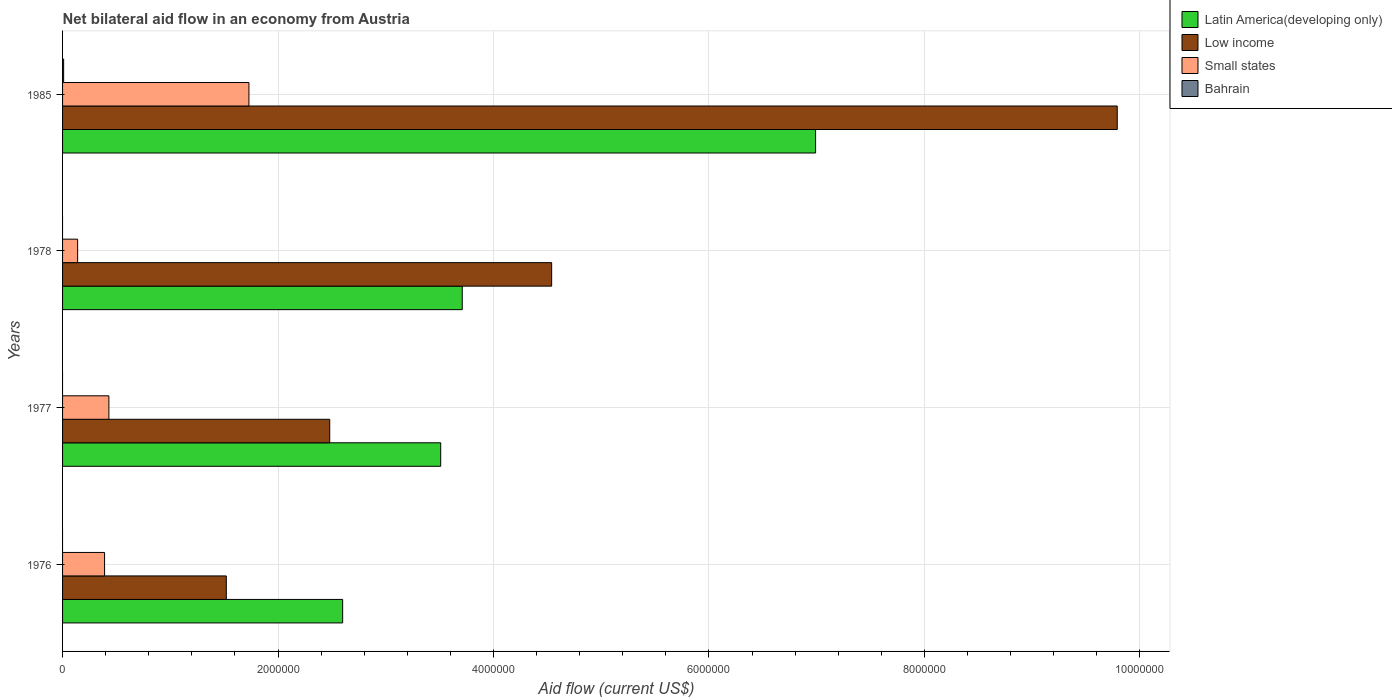How many different coloured bars are there?
Offer a terse response. 4. Are the number of bars per tick equal to the number of legend labels?
Your response must be concise. No. Are the number of bars on each tick of the Y-axis equal?
Provide a succinct answer. No. How many bars are there on the 1st tick from the top?
Offer a terse response. 4. How many bars are there on the 1st tick from the bottom?
Offer a terse response. 3. What is the net bilateral aid flow in Low income in 1978?
Provide a succinct answer. 4.54e+06. Across all years, what is the maximum net bilateral aid flow in Low income?
Provide a succinct answer. 9.79e+06. Across all years, what is the minimum net bilateral aid flow in Low income?
Your response must be concise. 1.52e+06. In which year was the net bilateral aid flow in Bahrain maximum?
Provide a succinct answer. 1985. What is the total net bilateral aid flow in Small states in the graph?
Provide a short and direct response. 2.69e+06. What is the difference between the net bilateral aid flow in Small states in 1976 and that in 1978?
Make the answer very short. 2.50e+05. What is the difference between the net bilateral aid flow in Latin America(developing only) in 1978 and the net bilateral aid flow in Bahrain in 1976?
Make the answer very short. 3.71e+06. What is the average net bilateral aid flow in Latin America(developing only) per year?
Make the answer very short. 4.20e+06. In the year 1985, what is the difference between the net bilateral aid flow in Low income and net bilateral aid flow in Latin America(developing only)?
Provide a short and direct response. 2.80e+06. What is the ratio of the net bilateral aid flow in Low income in 1977 to that in 1978?
Keep it short and to the point. 0.55. Is the net bilateral aid flow in Small states in 1977 less than that in 1978?
Your response must be concise. No. Is the difference between the net bilateral aid flow in Low income in 1976 and 1985 greater than the difference between the net bilateral aid flow in Latin America(developing only) in 1976 and 1985?
Your response must be concise. No. What is the difference between the highest and the second highest net bilateral aid flow in Latin America(developing only)?
Your answer should be compact. 3.28e+06. What is the difference between the highest and the lowest net bilateral aid flow in Low income?
Give a very brief answer. 8.27e+06. Is the sum of the net bilateral aid flow in Low income in 1976 and 1985 greater than the maximum net bilateral aid flow in Latin America(developing only) across all years?
Make the answer very short. Yes. Is it the case that in every year, the sum of the net bilateral aid flow in Low income and net bilateral aid flow in Small states is greater than the sum of net bilateral aid flow in Bahrain and net bilateral aid flow in Latin America(developing only)?
Your answer should be compact. No. Is it the case that in every year, the sum of the net bilateral aid flow in Latin America(developing only) and net bilateral aid flow in Bahrain is greater than the net bilateral aid flow in Low income?
Give a very brief answer. No. How many bars are there?
Provide a short and direct response. 13. Are all the bars in the graph horizontal?
Your answer should be compact. Yes. What is the difference between two consecutive major ticks on the X-axis?
Keep it short and to the point. 2.00e+06. Does the graph contain any zero values?
Your answer should be very brief. Yes. What is the title of the graph?
Give a very brief answer. Net bilateral aid flow in an economy from Austria. Does "Euro area" appear as one of the legend labels in the graph?
Offer a terse response. No. What is the label or title of the Y-axis?
Make the answer very short. Years. What is the Aid flow (current US$) in Latin America(developing only) in 1976?
Make the answer very short. 2.60e+06. What is the Aid flow (current US$) in Low income in 1976?
Your answer should be very brief. 1.52e+06. What is the Aid flow (current US$) of Small states in 1976?
Provide a short and direct response. 3.90e+05. What is the Aid flow (current US$) in Latin America(developing only) in 1977?
Give a very brief answer. 3.51e+06. What is the Aid flow (current US$) in Low income in 1977?
Keep it short and to the point. 2.48e+06. What is the Aid flow (current US$) in Small states in 1977?
Make the answer very short. 4.30e+05. What is the Aid flow (current US$) in Latin America(developing only) in 1978?
Offer a very short reply. 3.71e+06. What is the Aid flow (current US$) in Low income in 1978?
Offer a very short reply. 4.54e+06. What is the Aid flow (current US$) of Latin America(developing only) in 1985?
Make the answer very short. 6.99e+06. What is the Aid flow (current US$) of Low income in 1985?
Offer a terse response. 9.79e+06. What is the Aid flow (current US$) of Small states in 1985?
Provide a short and direct response. 1.73e+06. What is the Aid flow (current US$) of Bahrain in 1985?
Make the answer very short. 10000. Across all years, what is the maximum Aid flow (current US$) of Latin America(developing only)?
Ensure brevity in your answer.  6.99e+06. Across all years, what is the maximum Aid flow (current US$) in Low income?
Your response must be concise. 9.79e+06. Across all years, what is the maximum Aid flow (current US$) in Small states?
Make the answer very short. 1.73e+06. Across all years, what is the minimum Aid flow (current US$) in Latin America(developing only)?
Provide a succinct answer. 2.60e+06. Across all years, what is the minimum Aid flow (current US$) in Low income?
Provide a short and direct response. 1.52e+06. Across all years, what is the minimum Aid flow (current US$) of Small states?
Keep it short and to the point. 1.40e+05. What is the total Aid flow (current US$) of Latin America(developing only) in the graph?
Provide a succinct answer. 1.68e+07. What is the total Aid flow (current US$) of Low income in the graph?
Your response must be concise. 1.83e+07. What is the total Aid flow (current US$) in Small states in the graph?
Your answer should be compact. 2.69e+06. What is the difference between the Aid flow (current US$) of Latin America(developing only) in 1976 and that in 1977?
Your response must be concise. -9.10e+05. What is the difference between the Aid flow (current US$) in Low income in 1976 and that in 1977?
Ensure brevity in your answer.  -9.60e+05. What is the difference between the Aid flow (current US$) in Latin America(developing only) in 1976 and that in 1978?
Your answer should be compact. -1.11e+06. What is the difference between the Aid flow (current US$) in Low income in 1976 and that in 1978?
Your answer should be very brief. -3.02e+06. What is the difference between the Aid flow (current US$) of Small states in 1976 and that in 1978?
Provide a succinct answer. 2.50e+05. What is the difference between the Aid flow (current US$) of Latin America(developing only) in 1976 and that in 1985?
Your answer should be compact. -4.39e+06. What is the difference between the Aid flow (current US$) of Low income in 1976 and that in 1985?
Keep it short and to the point. -8.27e+06. What is the difference between the Aid flow (current US$) of Small states in 1976 and that in 1985?
Your answer should be very brief. -1.34e+06. What is the difference between the Aid flow (current US$) of Low income in 1977 and that in 1978?
Your response must be concise. -2.06e+06. What is the difference between the Aid flow (current US$) in Latin America(developing only) in 1977 and that in 1985?
Offer a very short reply. -3.48e+06. What is the difference between the Aid flow (current US$) in Low income in 1977 and that in 1985?
Make the answer very short. -7.31e+06. What is the difference between the Aid flow (current US$) of Small states in 1977 and that in 1985?
Offer a terse response. -1.30e+06. What is the difference between the Aid flow (current US$) in Latin America(developing only) in 1978 and that in 1985?
Ensure brevity in your answer.  -3.28e+06. What is the difference between the Aid flow (current US$) in Low income in 1978 and that in 1985?
Give a very brief answer. -5.25e+06. What is the difference between the Aid flow (current US$) of Small states in 1978 and that in 1985?
Provide a succinct answer. -1.59e+06. What is the difference between the Aid flow (current US$) in Latin America(developing only) in 1976 and the Aid flow (current US$) in Low income in 1977?
Your answer should be compact. 1.20e+05. What is the difference between the Aid flow (current US$) in Latin America(developing only) in 1976 and the Aid flow (current US$) in Small states in 1977?
Offer a terse response. 2.17e+06. What is the difference between the Aid flow (current US$) in Low income in 1976 and the Aid flow (current US$) in Small states in 1977?
Provide a succinct answer. 1.09e+06. What is the difference between the Aid flow (current US$) in Latin America(developing only) in 1976 and the Aid flow (current US$) in Low income in 1978?
Give a very brief answer. -1.94e+06. What is the difference between the Aid flow (current US$) of Latin America(developing only) in 1976 and the Aid flow (current US$) of Small states in 1978?
Keep it short and to the point. 2.46e+06. What is the difference between the Aid flow (current US$) in Low income in 1976 and the Aid flow (current US$) in Small states in 1978?
Make the answer very short. 1.38e+06. What is the difference between the Aid flow (current US$) in Latin America(developing only) in 1976 and the Aid flow (current US$) in Low income in 1985?
Provide a short and direct response. -7.19e+06. What is the difference between the Aid flow (current US$) of Latin America(developing only) in 1976 and the Aid flow (current US$) of Small states in 1985?
Ensure brevity in your answer.  8.70e+05. What is the difference between the Aid flow (current US$) of Latin America(developing only) in 1976 and the Aid flow (current US$) of Bahrain in 1985?
Provide a short and direct response. 2.59e+06. What is the difference between the Aid flow (current US$) of Low income in 1976 and the Aid flow (current US$) of Bahrain in 1985?
Your response must be concise. 1.51e+06. What is the difference between the Aid flow (current US$) in Latin America(developing only) in 1977 and the Aid flow (current US$) in Low income in 1978?
Make the answer very short. -1.03e+06. What is the difference between the Aid flow (current US$) of Latin America(developing only) in 1977 and the Aid flow (current US$) of Small states in 1978?
Provide a succinct answer. 3.37e+06. What is the difference between the Aid flow (current US$) of Low income in 1977 and the Aid flow (current US$) of Small states in 1978?
Your answer should be very brief. 2.34e+06. What is the difference between the Aid flow (current US$) in Latin America(developing only) in 1977 and the Aid flow (current US$) in Low income in 1985?
Make the answer very short. -6.28e+06. What is the difference between the Aid flow (current US$) in Latin America(developing only) in 1977 and the Aid flow (current US$) in Small states in 1985?
Your answer should be compact. 1.78e+06. What is the difference between the Aid flow (current US$) in Latin America(developing only) in 1977 and the Aid flow (current US$) in Bahrain in 1985?
Ensure brevity in your answer.  3.50e+06. What is the difference between the Aid flow (current US$) in Low income in 1977 and the Aid flow (current US$) in Small states in 1985?
Provide a short and direct response. 7.50e+05. What is the difference between the Aid flow (current US$) of Low income in 1977 and the Aid flow (current US$) of Bahrain in 1985?
Offer a terse response. 2.47e+06. What is the difference between the Aid flow (current US$) in Latin America(developing only) in 1978 and the Aid flow (current US$) in Low income in 1985?
Offer a very short reply. -6.08e+06. What is the difference between the Aid flow (current US$) of Latin America(developing only) in 1978 and the Aid flow (current US$) of Small states in 1985?
Provide a short and direct response. 1.98e+06. What is the difference between the Aid flow (current US$) of Latin America(developing only) in 1978 and the Aid flow (current US$) of Bahrain in 1985?
Ensure brevity in your answer.  3.70e+06. What is the difference between the Aid flow (current US$) in Low income in 1978 and the Aid flow (current US$) in Small states in 1985?
Offer a terse response. 2.81e+06. What is the difference between the Aid flow (current US$) of Low income in 1978 and the Aid flow (current US$) of Bahrain in 1985?
Ensure brevity in your answer.  4.53e+06. What is the difference between the Aid flow (current US$) of Small states in 1978 and the Aid flow (current US$) of Bahrain in 1985?
Ensure brevity in your answer.  1.30e+05. What is the average Aid flow (current US$) of Latin America(developing only) per year?
Provide a short and direct response. 4.20e+06. What is the average Aid flow (current US$) of Low income per year?
Your response must be concise. 4.58e+06. What is the average Aid flow (current US$) of Small states per year?
Give a very brief answer. 6.72e+05. What is the average Aid flow (current US$) of Bahrain per year?
Ensure brevity in your answer.  2500. In the year 1976, what is the difference between the Aid flow (current US$) of Latin America(developing only) and Aid flow (current US$) of Low income?
Your answer should be very brief. 1.08e+06. In the year 1976, what is the difference between the Aid flow (current US$) of Latin America(developing only) and Aid flow (current US$) of Small states?
Your answer should be very brief. 2.21e+06. In the year 1976, what is the difference between the Aid flow (current US$) in Low income and Aid flow (current US$) in Small states?
Make the answer very short. 1.13e+06. In the year 1977, what is the difference between the Aid flow (current US$) in Latin America(developing only) and Aid flow (current US$) in Low income?
Give a very brief answer. 1.03e+06. In the year 1977, what is the difference between the Aid flow (current US$) in Latin America(developing only) and Aid flow (current US$) in Small states?
Offer a very short reply. 3.08e+06. In the year 1977, what is the difference between the Aid flow (current US$) in Low income and Aid flow (current US$) in Small states?
Your answer should be compact. 2.05e+06. In the year 1978, what is the difference between the Aid flow (current US$) of Latin America(developing only) and Aid flow (current US$) of Low income?
Make the answer very short. -8.30e+05. In the year 1978, what is the difference between the Aid flow (current US$) of Latin America(developing only) and Aid flow (current US$) of Small states?
Your answer should be compact. 3.57e+06. In the year 1978, what is the difference between the Aid flow (current US$) in Low income and Aid flow (current US$) in Small states?
Provide a short and direct response. 4.40e+06. In the year 1985, what is the difference between the Aid flow (current US$) in Latin America(developing only) and Aid flow (current US$) in Low income?
Make the answer very short. -2.80e+06. In the year 1985, what is the difference between the Aid flow (current US$) of Latin America(developing only) and Aid flow (current US$) of Small states?
Your answer should be compact. 5.26e+06. In the year 1985, what is the difference between the Aid flow (current US$) of Latin America(developing only) and Aid flow (current US$) of Bahrain?
Your answer should be very brief. 6.98e+06. In the year 1985, what is the difference between the Aid flow (current US$) in Low income and Aid flow (current US$) in Small states?
Make the answer very short. 8.06e+06. In the year 1985, what is the difference between the Aid flow (current US$) of Low income and Aid flow (current US$) of Bahrain?
Your response must be concise. 9.78e+06. In the year 1985, what is the difference between the Aid flow (current US$) of Small states and Aid flow (current US$) of Bahrain?
Your answer should be compact. 1.72e+06. What is the ratio of the Aid flow (current US$) in Latin America(developing only) in 1976 to that in 1977?
Make the answer very short. 0.74. What is the ratio of the Aid flow (current US$) in Low income in 1976 to that in 1977?
Your answer should be compact. 0.61. What is the ratio of the Aid flow (current US$) of Small states in 1976 to that in 1977?
Provide a short and direct response. 0.91. What is the ratio of the Aid flow (current US$) in Latin America(developing only) in 1976 to that in 1978?
Offer a very short reply. 0.7. What is the ratio of the Aid flow (current US$) of Low income in 1976 to that in 1978?
Provide a short and direct response. 0.33. What is the ratio of the Aid flow (current US$) in Small states in 1976 to that in 1978?
Ensure brevity in your answer.  2.79. What is the ratio of the Aid flow (current US$) in Latin America(developing only) in 1976 to that in 1985?
Offer a terse response. 0.37. What is the ratio of the Aid flow (current US$) in Low income in 1976 to that in 1985?
Your answer should be compact. 0.16. What is the ratio of the Aid flow (current US$) in Small states in 1976 to that in 1985?
Your response must be concise. 0.23. What is the ratio of the Aid flow (current US$) of Latin America(developing only) in 1977 to that in 1978?
Ensure brevity in your answer.  0.95. What is the ratio of the Aid flow (current US$) of Low income in 1977 to that in 1978?
Ensure brevity in your answer.  0.55. What is the ratio of the Aid flow (current US$) in Small states in 1977 to that in 1978?
Offer a very short reply. 3.07. What is the ratio of the Aid flow (current US$) of Latin America(developing only) in 1977 to that in 1985?
Give a very brief answer. 0.5. What is the ratio of the Aid flow (current US$) of Low income in 1977 to that in 1985?
Ensure brevity in your answer.  0.25. What is the ratio of the Aid flow (current US$) of Small states in 1977 to that in 1985?
Provide a succinct answer. 0.25. What is the ratio of the Aid flow (current US$) in Latin America(developing only) in 1978 to that in 1985?
Provide a succinct answer. 0.53. What is the ratio of the Aid flow (current US$) in Low income in 1978 to that in 1985?
Make the answer very short. 0.46. What is the ratio of the Aid flow (current US$) of Small states in 1978 to that in 1985?
Provide a succinct answer. 0.08. What is the difference between the highest and the second highest Aid flow (current US$) in Latin America(developing only)?
Your answer should be compact. 3.28e+06. What is the difference between the highest and the second highest Aid flow (current US$) in Low income?
Your response must be concise. 5.25e+06. What is the difference between the highest and the second highest Aid flow (current US$) of Small states?
Make the answer very short. 1.30e+06. What is the difference between the highest and the lowest Aid flow (current US$) in Latin America(developing only)?
Keep it short and to the point. 4.39e+06. What is the difference between the highest and the lowest Aid flow (current US$) in Low income?
Give a very brief answer. 8.27e+06. What is the difference between the highest and the lowest Aid flow (current US$) of Small states?
Make the answer very short. 1.59e+06. What is the difference between the highest and the lowest Aid flow (current US$) of Bahrain?
Keep it short and to the point. 10000. 